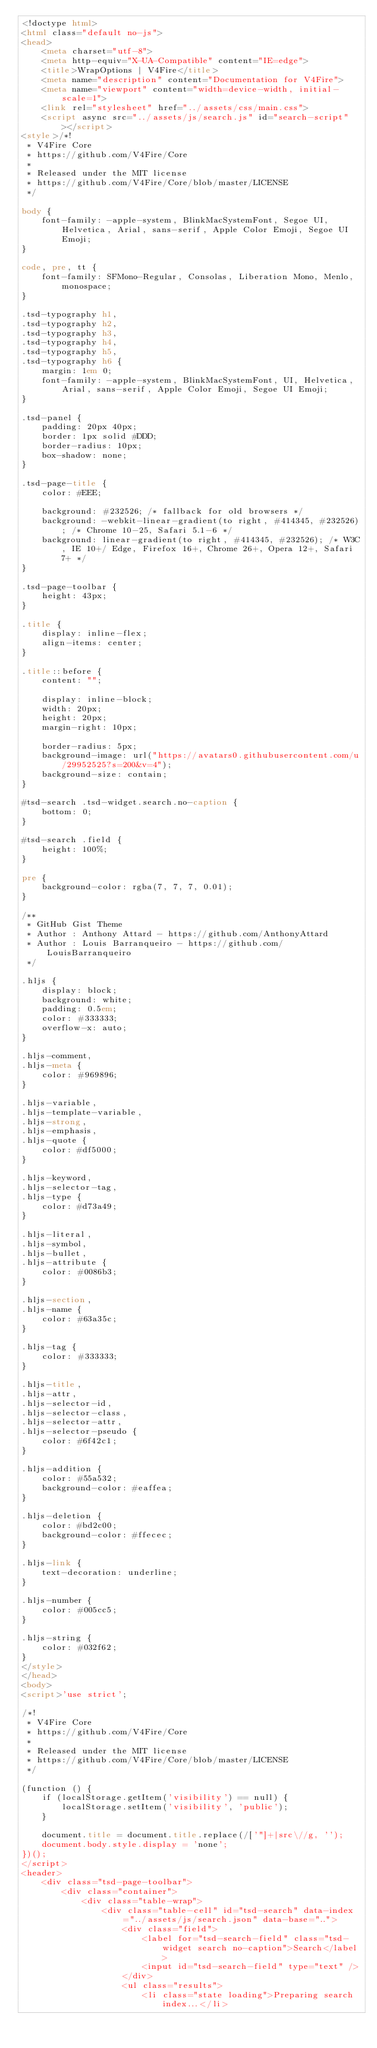<code> <loc_0><loc_0><loc_500><loc_500><_HTML_><!doctype html>
<html class="default no-js">
<head>
	<meta charset="utf-8">
	<meta http-equiv="X-UA-Compatible" content="IE=edge">
	<title>WrapOptions | V4Fire</title>
	<meta name="description" content="Documentation for V4Fire">
	<meta name="viewport" content="width=device-width, initial-scale=1">
	<link rel="stylesheet" href="../assets/css/main.css">
	<script async src="../assets/js/search.js" id="search-script"></script>
<style>/*!
 * V4Fire Core
 * https://github.com/V4Fire/Core
 *
 * Released under the MIT license
 * https://github.com/V4Fire/Core/blob/master/LICENSE
 */

body {
	font-family: -apple-system, BlinkMacSystemFont, Segoe UI, Helvetica, Arial, sans-serif, Apple Color Emoji, Segoe UI Emoji;
}

code, pre, tt {
	font-family: SFMono-Regular, Consolas, Liberation Mono, Menlo, monospace;
}

.tsd-typography h1,
.tsd-typography h2,
.tsd-typography h3,
.tsd-typography h4,
.tsd-typography h5,
.tsd-typography h6 {
	margin: 1em 0;
	font-family: -apple-system, BlinkMacSystemFont, UI, Helvetica, Arial, sans-serif, Apple Color Emoji, Segoe UI Emoji;
}

.tsd-panel {
	padding: 20px 40px;
	border: 1px solid #DDD;
	border-radius: 10px;
	box-shadow: none;
}

.tsd-page-title {
	color: #EEE;

	background: #232526; /* fallback for old browsers */
	background: -webkit-linear-gradient(to right, #414345, #232526); /* Chrome 10-25, Safari 5.1-6 */
	background: linear-gradient(to right, #414345, #232526); /* W3C, IE 10+/ Edge, Firefox 16+, Chrome 26+, Opera 12+, Safari 7+ */
}

.tsd-page-toolbar {
	height: 43px;
}

.title {
	display: inline-flex;
	align-items: center;
}

.title::before {
	content: "";

	display: inline-block;
	width: 20px;
	height: 20px;
	margin-right: 10px;

	border-radius: 5px;
	background-image: url("https://avatars0.githubusercontent.com/u/29952525?s=200&v=4");
	background-size: contain;
}

#tsd-search .tsd-widget.search.no-caption {
	bottom: 0;
}

#tsd-search .field {
	height: 100%;
}

pre {
	background-color: rgba(7, 7, 7, 0.01);
}

/**
 * GitHub Gist Theme
 * Author : Anthony Attard - https://github.com/AnthonyAttard
 * Author : Louis Barranqueiro - https://github.com/LouisBarranqueiro
 */

.hljs {
	display: block;
	background: white;
	padding: 0.5em;
	color: #333333;
	overflow-x: auto;
}

.hljs-comment,
.hljs-meta {
	color: #969896;
}

.hljs-variable,
.hljs-template-variable,
.hljs-strong,
.hljs-emphasis,
.hljs-quote {
	color: #df5000;
}

.hljs-keyword,
.hljs-selector-tag,
.hljs-type {
	color: #d73a49;
}

.hljs-literal,
.hljs-symbol,
.hljs-bullet,
.hljs-attribute {
	color: #0086b3;
}

.hljs-section,
.hljs-name {
	color: #63a35c;
}

.hljs-tag {
	color: #333333;
}

.hljs-title,
.hljs-attr,
.hljs-selector-id,
.hljs-selector-class,
.hljs-selector-attr,
.hljs-selector-pseudo {
	color: #6f42c1;
}

.hljs-addition {
	color: #55a532;
	background-color: #eaffea;
}

.hljs-deletion {
	color: #bd2c00;
	background-color: #ffecec;
}

.hljs-link {
	text-decoration: underline;
}

.hljs-number {
	color: #005cc5;
}

.hljs-string {
	color: #032f62;
}
</style>
</head>
<body>
<script>'use strict';

/*!
 * V4Fire Core
 * https://github.com/V4Fire/Core
 *
 * Released under the MIT license
 * https://github.com/V4Fire/Core/blob/master/LICENSE
 */

(function () {
	if (localStorage.getItem('visibility') == null) {
		localStorage.setItem('visibility', 'public');
	}

	document.title = document.title.replace(/['"]+|src\//g, '');
	document.body.style.display = 'none';
})();
</script>
<header>
	<div class="tsd-page-toolbar">
		<div class="container">
			<div class="table-wrap">
				<div class="table-cell" id="tsd-search" data-index="../assets/js/search.json" data-base="..">
					<div class="field">
						<label for="tsd-search-field" class="tsd-widget search no-caption">Search</label>
						<input id="tsd-search-field" type="text" />
					</div>
					<ul class="results">
						<li class="state loading">Preparing search index...</li></code> 